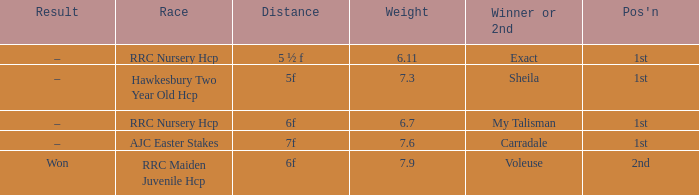What is the largest weight wth a Result of –, and a Distance of 7f? 7.6. 